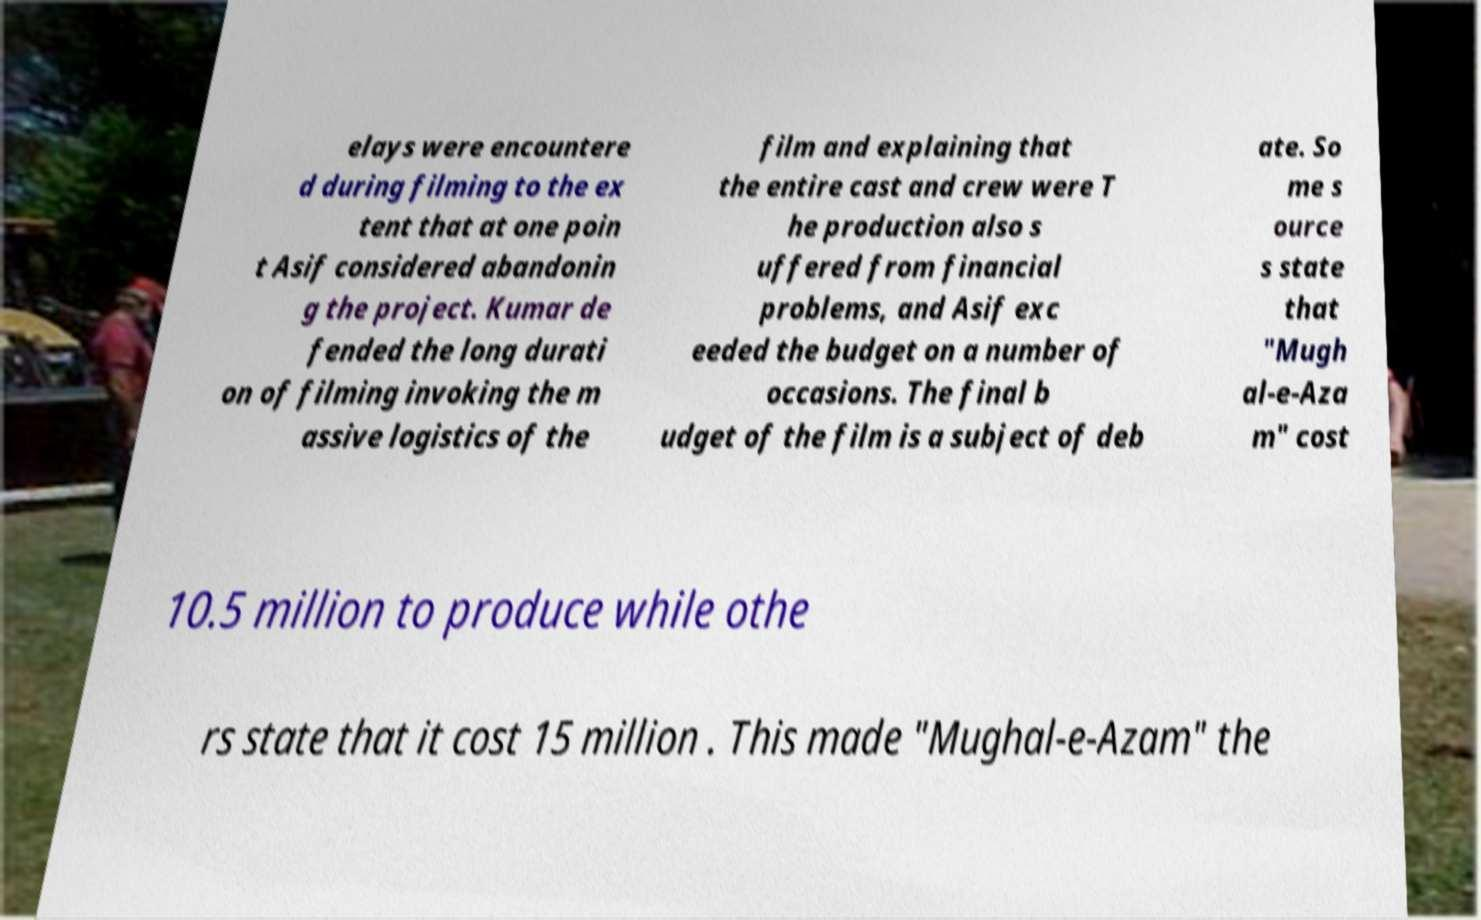For documentation purposes, I need the text within this image transcribed. Could you provide that? elays were encountere d during filming to the ex tent that at one poin t Asif considered abandonin g the project. Kumar de fended the long durati on of filming invoking the m assive logistics of the film and explaining that the entire cast and crew were T he production also s uffered from financial problems, and Asif exc eeded the budget on a number of occasions. The final b udget of the film is a subject of deb ate. So me s ource s state that "Mugh al-e-Aza m" cost 10.5 million to produce while othe rs state that it cost 15 million . This made "Mughal-e-Azam" the 